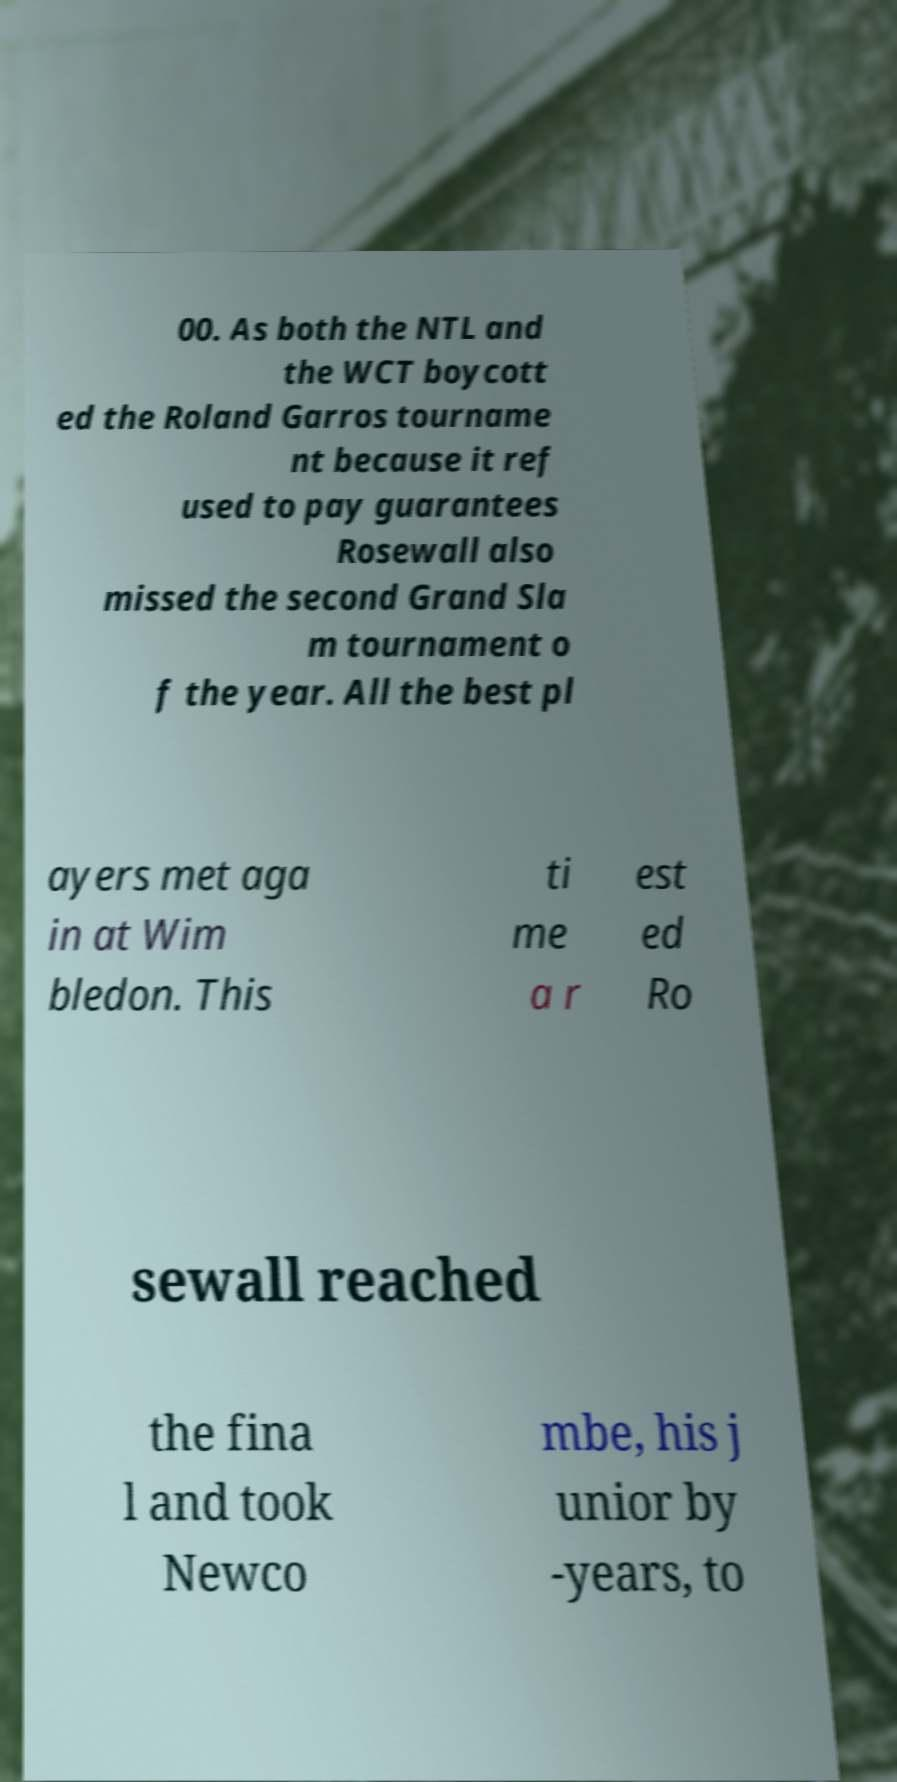Please read and relay the text visible in this image. What does it say? 00. As both the NTL and the WCT boycott ed the Roland Garros tourname nt because it ref used to pay guarantees Rosewall also missed the second Grand Sla m tournament o f the year. All the best pl ayers met aga in at Wim bledon. This ti me a r est ed Ro sewall reached the fina l and took Newco mbe, his j unior by -years, to 